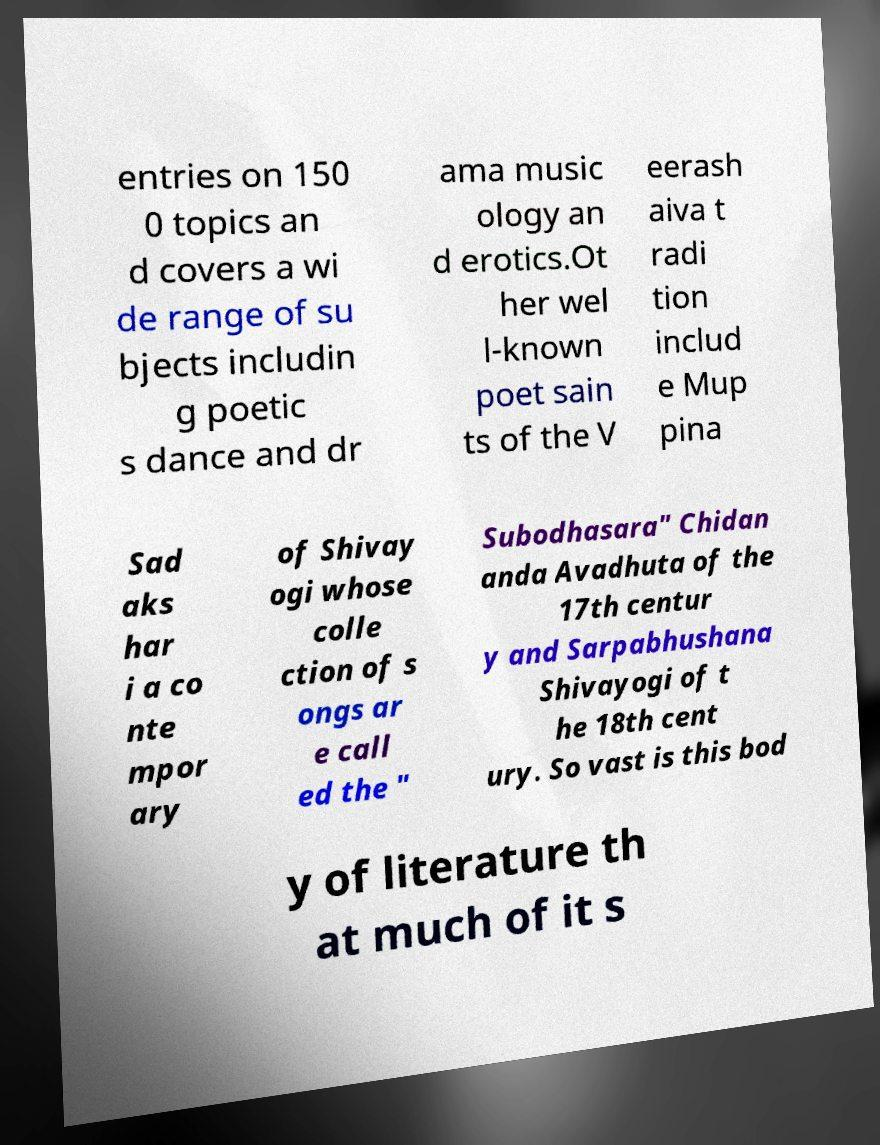Please identify and transcribe the text found in this image. entries on 150 0 topics an d covers a wi de range of su bjects includin g poetic s dance and dr ama music ology an d erotics.Ot her wel l-known poet sain ts of the V eerash aiva t radi tion includ e Mup pina Sad aks har i a co nte mpor ary of Shivay ogi whose colle ction of s ongs ar e call ed the " Subodhasara" Chidan anda Avadhuta of the 17th centur y and Sarpabhushana Shivayogi of t he 18th cent ury. So vast is this bod y of literature th at much of it s 